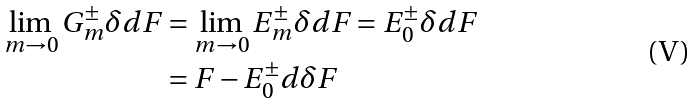Convert formula to latex. <formula><loc_0><loc_0><loc_500><loc_500>\lim _ { m \to 0 } G _ { m } ^ { \pm } \delta d F & = \lim _ { m \to 0 } E _ { m } ^ { \pm } \delta d F = E _ { 0 } ^ { \pm } \delta d F \\ & = F - E _ { 0 } ^ { \pm } d \delta F</formula> 